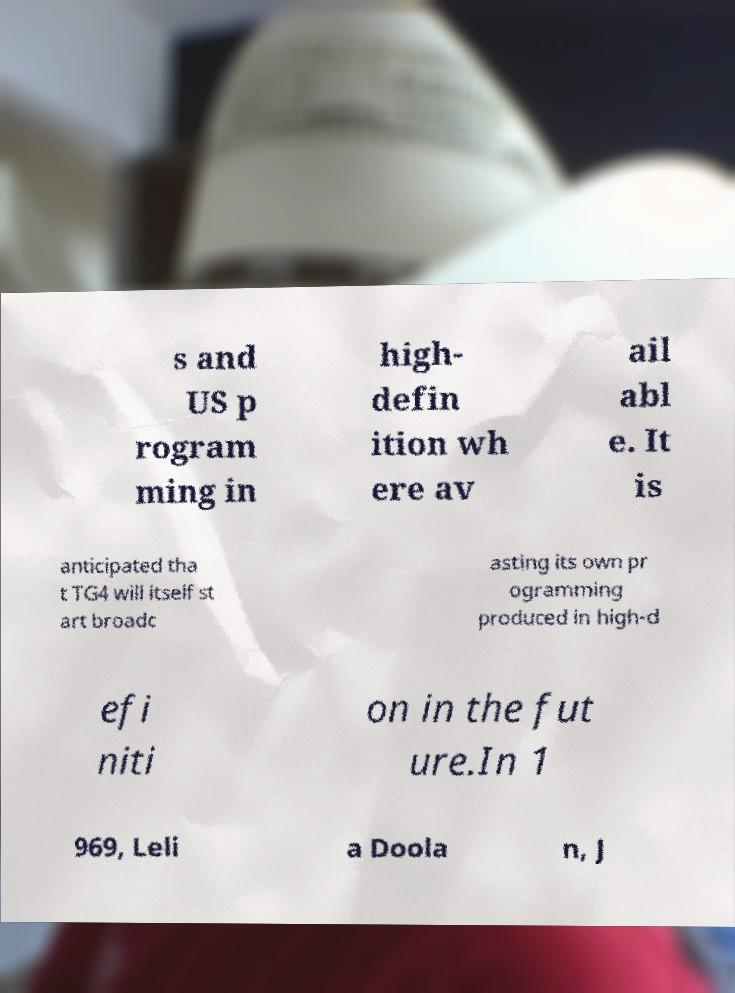What messages or text are displayed in this image? I need them in a readable, typed format. s and US p rogram ming in high- defin ition wh ere av ail abl e. It is anticipated tha t TG4 will itself st art broadc asting its own pr ogramming produced in high-d efi niti on in the fut ure.In 1 969, Leli a Doola n, J 